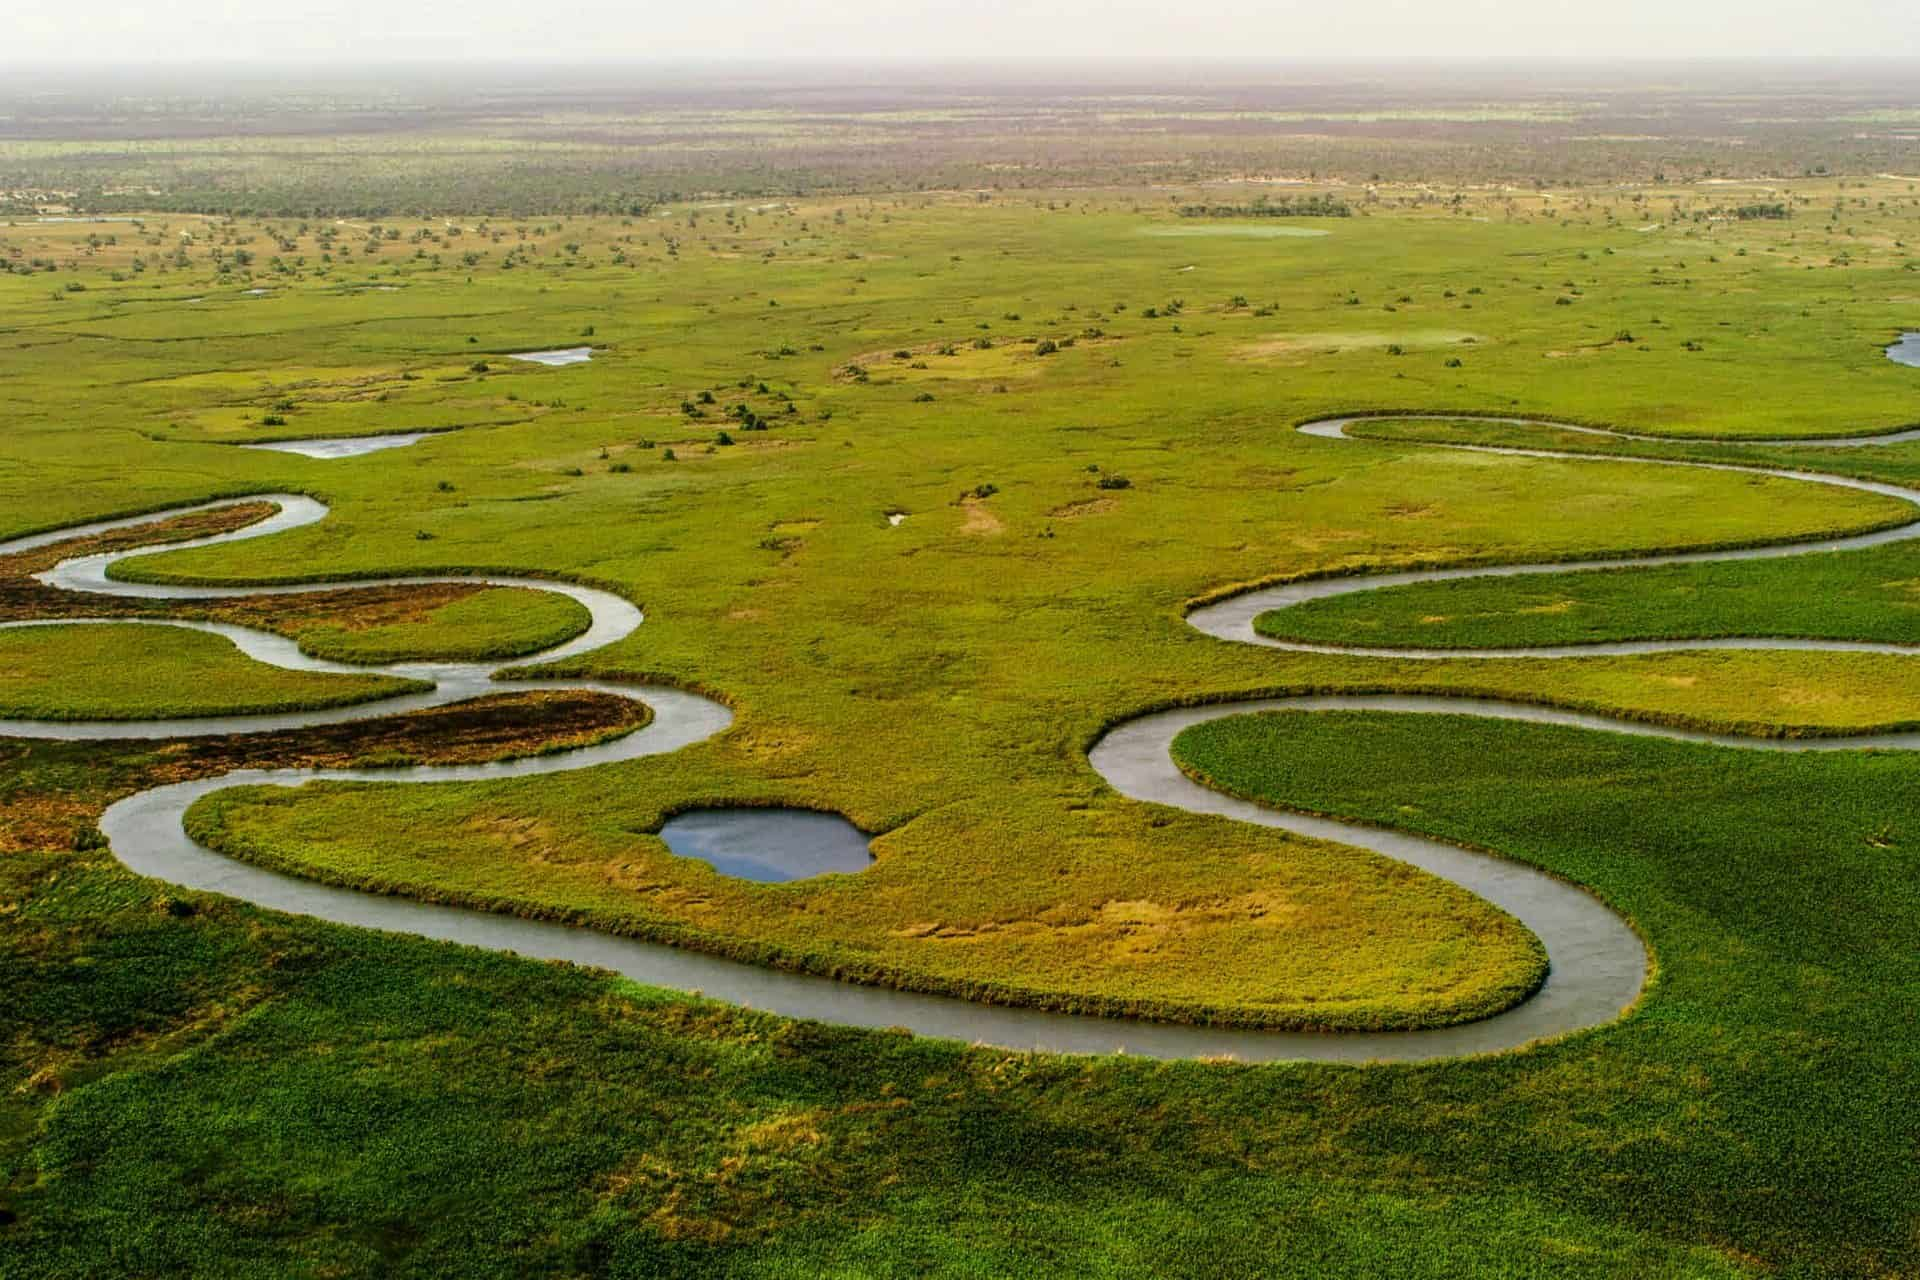How do the seasonal changes affect the Okavango Delta? The Okavango Delta experiences dramatic changes with the seasons. During the wet season, typically from January to February, flooding from upstream in Angola brings an influx of water that spreads out over the delta, revitalizing it and providing essential water to the flora and fauna. In contrast, during the dry season, water levels retract, and the landscape becomes more arid, prompting animals to congregate around the remaining water sources, which leads to spectacular wildlife viewing opportunities. The dynamic water levels also influence the distribution of animal populations and vegetation types throughout the delta. 